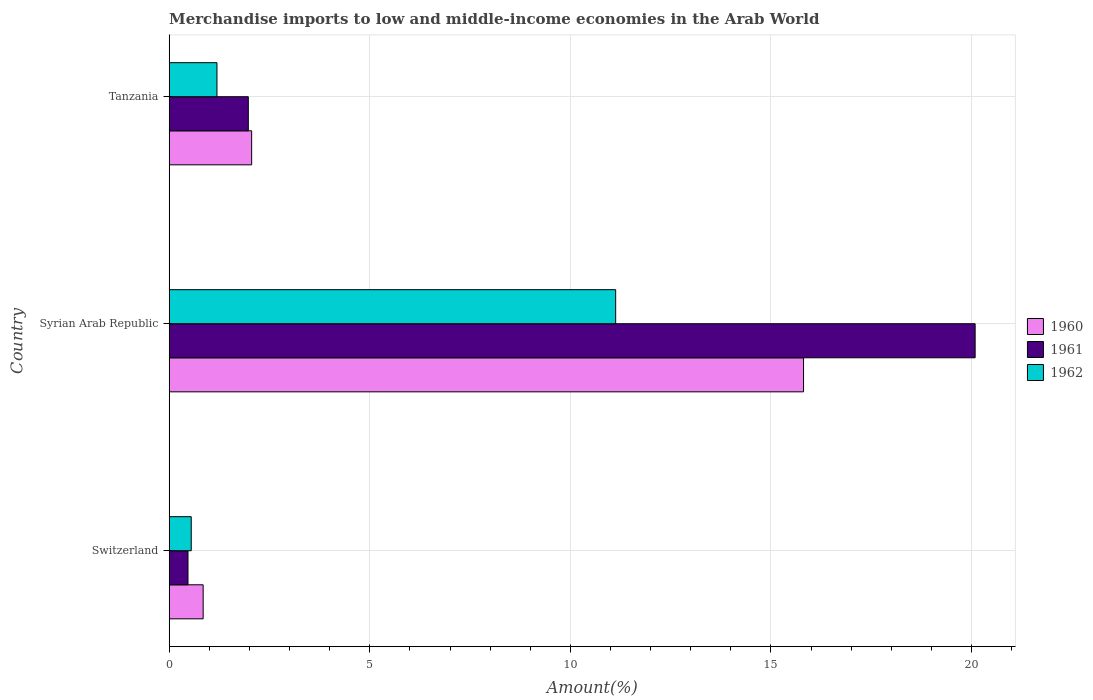How many groups of bars are there?
Make the answer very short. 3. Are the number of bars per tick equal to the number of legend labels?
Give a very brief answer. Yes. Are the number of bars on each tick of the Y-axis equal?
Give a very brief answer. Yes. How many bars are there on the 1st tick from the top?
Make the answer very short. 3. How many bars are there on the 1st tick from the bottom?
Offer a terse response. 3. What is the label of the 3rd group of bars from the top?
Provide a succinct answer. Switzerland. In how many cases, is the number of bars for a given country not equal to the number of legend labels?
Your response must be concise. 0. What is the percentage of amount earned from merchandise imports in 1961 in Syrian Arab Republic?
Your answer should be very brief. 20.09. Across all countries, what is the maximum percentage of amount earned from merchandise imports in 1961?
Your response must be concise. 20.09. Across all countries, what is the minimum percentage of amount earned from merchandise imports in 1961?
Your answer should be compact. 0.47. In which country was the percentage of amount earned from merchandise imports in 1960 maximum?
Your response must be concise. Syrian Arab Republic. In which country was the percentage of amount earned from merchandise imports in 1961 minimum?
Give a very brief answer. Switzerland. What is the total percentage of amount earned from merchandise imports in 1962 in the graph?
Your answer should be very brief. 12.87. What is the difference between the percentage of amount earned from merchandise imports in 1961 in Switzerland and that in Tanzania?
Your answer should be very brief. -1.5. What is the difference between the percentage of amount earned from merchandise imports in 1960 in Switzerland and the percentage of amount earned from merchandise imports in 1962 in Tanzania?
Give a very brief answer. -0.34. What is the average percentage of amount earned from merchandise imports in 1960 per country?
Offer a terse response. 6.24. What is the difference between the percentage of amount earned from merchandise imports in 1961 and percentage of amount earned from merchandise imports in 1960 in Tanzania?
Keep it short and to the point. -0.08. What is the ratio of the percentage of amount earned from merchandise imports in 1961 in Syrian Arab Republic to that in Tanzania?
Provide a succinct answer. 10.19. Is the percentage of amount earned from merchandise imports in 1960 in Switzerland less than that in Syrian Arab Republic?
Offer a terse response. Yes. What is the difference between the highest and the second highest percentage of amount earned from merchandise imports in 1960?
Provide a succinct answer. 13.76. What is the difference between the highest and the lowest percentage of amount earned from merchandise imports in 1961?
Offer a terse response. 19.62. In how many countries, is the percentage of amount earned from merchandise imports in 1960 greater than the average percentage of amount earned from merchandise imports in 1960 taken over all countries?
Keep it short and to the point. 1. Is the sum of the percentage of amount earned from merchandise imports in 1960 in Switzerland and Syrian Arab Republic greater than the maximum percentage of amount earned from merchandise imports in 1961 across all countries?
Your answer should be very brief. No. What does the 2nd bar from the bottom in Syrian Arab Republic represents?
Ensure brevity in your answer.  1961. How many bars are there?
Offer a terse response. 9. How many countries are there in the graph?
Offer a very short reply. 3. What is the difference between two consecutive major ticks on the X-axis?
Your answer should be very brief. 5. Where does the legend appear in the graph?
Keep it short and to the point. Center right. How are the legend labels stacked?
Give a very brief answer. Vertical. What is the title of the graph?
Your response must be concise. Merchandise imports to low and middle-income economies in the Arab World. What is the label or title of the X-axis?
Provide a short and direct response. Amount(%). What is the label or title of the Y-axis?
Your answer should be compact. Country. What is the Amount(%) of 1960 in Switzerland?
Make the answer very short. 0.85. What is the Amount(%) of 1961 in Switzerland?
Keep it short and to the point. 0.47. What is the Amount(%) in 1962 in Switzerland?
Your answer should be very brief. 0.55. What is the Amount(%) in 1960 in Syrian Arab Republic?
Your answer should be compact. 15.81. What is the Amount(%) of 1961 in Syrian Arab Republic?
Offer a terse response. 20.09. What is the Amount(%) in 1962 in Syrian Arab Republic?
Keep it short and to the point. 11.13. What is the Amount(%) in 1960 in Tanzania?
Offer a very short reply. 2.06. What is the Amount(%) of 1961 in Tanzania?
Keep it short and to the point. 1.97. What is the Amount(%) in 1962 in Tanzania?
Your answer should be very brief. 1.19. Across all countries, what is the maximum Amount(%) in 1960?
Make the answer very short. 15.81. Across all countries, what is the maximum Amount(%) in 1961?
Provide a succinct answer. 20.09. Across all countries, what is the maximum Amount(%) of 1962?
Your answer should be compact. 11.13. Across all countries, what is the minimum Amount(%) in 1960?
Give a very brief answer. 0.85. Across all countries, what is the minimum Amount(%) of 1961?
Offer a terse response. 0.47. Across all countries, what is the minimum Amount(%) in 1962?
Give a very brief answer. 0.55. What is the total Amount(%) in 1960 in the graph?
Your answer should be compact. 18.72. What is the total Amount(%) of 1961 in the graph?
Your response must be concise. 22.53. What is the total Amount(%) of 1962 in the graph?
Keep it short and to the point. 12.87. What is the difference between the Amount(%) of 1960 in Switzerland and that in Syrian Arab Republic?
Offer a terse response. -14.97. What is the difference between the Amount(%) of 1961 in Switzerland and that in Syrian Arab Republic?
Provide a succinct answer. -19.62. What is the difference between the Amount(%) of 1962 in Switzerland and that in Syrian Arab Republic?
Give a very brief answer. -10.58. What is the difference between the Amount(%) in 1960 in Switzerland and that in Tanzania?
Your response must be concise. -1.21. What is the difference between the Amount(%) in 1961 in Switzerland and that in Tanzania?
Offer a very short reply. -1.5. What is the difference between the Amount(%) of 1962 in Switzerland and that in Tanzania?
Provide a short and direct response. -0.64. What is the difference between the Amount(%) in 1960 in Syrian Arab Republic and that in Tanzania?
Ensure brevity in your answer.  13.76. What is the difference between the Amount(%) in 1961 in Syrian Arab Republic and that in Tanzania?
Make the answer very short. 18.12. What is the difference between the Amount(%) in 1962 in Syrian Arab Republic and that in Tanzania?
Ensure brevity in your answer.  9.94. What is the difference between the Amount(%) in 1960 in Switzerland and the Amount(%) in 1961 in Syrian Arab Republic?
Provide a succinct answer. -19.25. What is the difference between the Amount(%) in 1960 in Switzerland and the Amount(%) in 1962 in Syrian Arab Republic?
Ensure brevity in your answer.  -10.28. What is the difference between the Amount(%) of 1961 in Switzerland and the Amount(%) of 1962 in Syrian Arab Republic?
Provide a short and direct response. -10.66. What is the difference between the Amount(%) in 1960 in Switzerland and the Amount(%) in 1961 in Tanzania?
Offer a very short reply. -1.13. What is the difference between the Amount(%) of 1960 in Switzerland and the Amount(%) of 1962 in Tanzania?
Make the answer very short. -0.34. What is the difference between the Amount(%) in 1961 in Switzerland and the Amount(%) in 1962 in Tanzania?
Offer a very short reply. -0.72. What is the difference between the Amount(%) in 1960 in Syrian Arab Republic and the Amount(%) in 1961 in Tanzania?
Your response must be concise. 13.84. What is the difference between the Amount(%) of 1960 in Syrian Arab Republic and the Amount(%) of 1962 in Tanzania?
Provide a succinct answer. 14.62. What is the difference between the Amount(%) in 1961 in Syrian Arab Republic and the Amount(%) in 1962 in Tanzania?
Give a very brief answer. 18.9. What is the average Amount(%) in 1960 per country?
Provide a succinct answer. 6.24. What is the average Amount(%) of 1961 per country?
Give a very brief answer. 7.51. What is the average Amount(%) of 1962 per country?
Provide a succinct answer. 4.29. What is the difference between the Amount(%) in 1960 and Amount(%) in 1961 in Switzerland?
Make the answer very short. 0.38. What is the difference between the Amount(%) of 1960 and Amount(%) of 1962 in Switzerland?
Offer a very short reply. 0.3. What is the difference between the Amount(%) of 1961 and Amount(%) of 1962 in Switzerland?
Make the answer very short. -0.08. What is the difference between the Amount(%) in 1960 and Amount(%) in 1961 in Syrian Arab Republic?
Give a very brief answer. -4.28. What is the difference between the Amount(%) of 1960 and Amount(%) of 1962 in Syrian Arab Republic?
Your response must be concise. 4.68. What is the difference between the Amount(%) in 1961 and Amount(%) in 1962 in Syrian Arab Republic?
Provide a succinct answer. 8.96. What is the difference between the Amount(%) of 1960 and Amount(%) of 1961 in Tanzania?
Your response must be concise. 0.08. What is the difference between the Amount(%) in 1960 and Amount(%) in 1962 in Tanzania?
Your response must be concise. 0.87. What is the difference between the Amount(%) of 1961 and Amount(%) of 1962 in Tanzania?
Your answer should be very brief. 0.78. What is the ratio of the Amount(%) in 1960 in Switzerland to that in Syrian Arab Republic?
Your response must be concise. 0.05. What is the ratio of the Amount(%) of 1961 in Switzerland to that in Syrian Arab Republic?
Give a very brief answer. 0.02. What is the ratio of the Amount(%) of 1962 in Switzerland to that in Syrian Arab Republic?
Keep it short and to the point. 0.05. What is the ratio of the Amount(%) of 1960 in Switzerland to that in Tanzania?
Offer a terse response. 0.41. What is the ratio of the Amount(%) in 1961 in Switzerland to that in Tanzania?
Keep it short and to the point. 0.24. What is the ratio of the Amount(%) of 1962 in Switzerland to that in Tanzania?
Give a very brief answer. 0.46. What is the ratio of the Amount(%) of 1960 in Syrian Arab Republic to that in Tanzania?
Your answer should be compact. 7.69. What is the ratio of the Amount(%) of 1961 in Syrian Arab Republic to that in Tanzania?
Your answer should be compact. 10.19. What is the ratio of the Amount(%) of 1962 in Syrian Arab Republic to that in Tanzania?
Your answer should be very brief. 9.35. What is the difference between the highest and the second highest Amount(%) of 1960?
Your answer should be very brief. 13.76. What is the difference between the highest and the second highest Amount(%) in 1961?
Provide a short and direct response. 18.12. What is the difference between the highest and the second highest Amount(%) of 1962?
Offer a very short reply. 9.94. What is the difference between the highest and the lowest Amount(%) in 1960?
Give a very brief answer. 14.97. What is the difference between the highest and the lowest Amount(%) in 1961?
Offer a very short reply. 19.62. What is the difference between the highest and the lowest Amount(%) in 1962?
Offer a terse response. 10.58. 